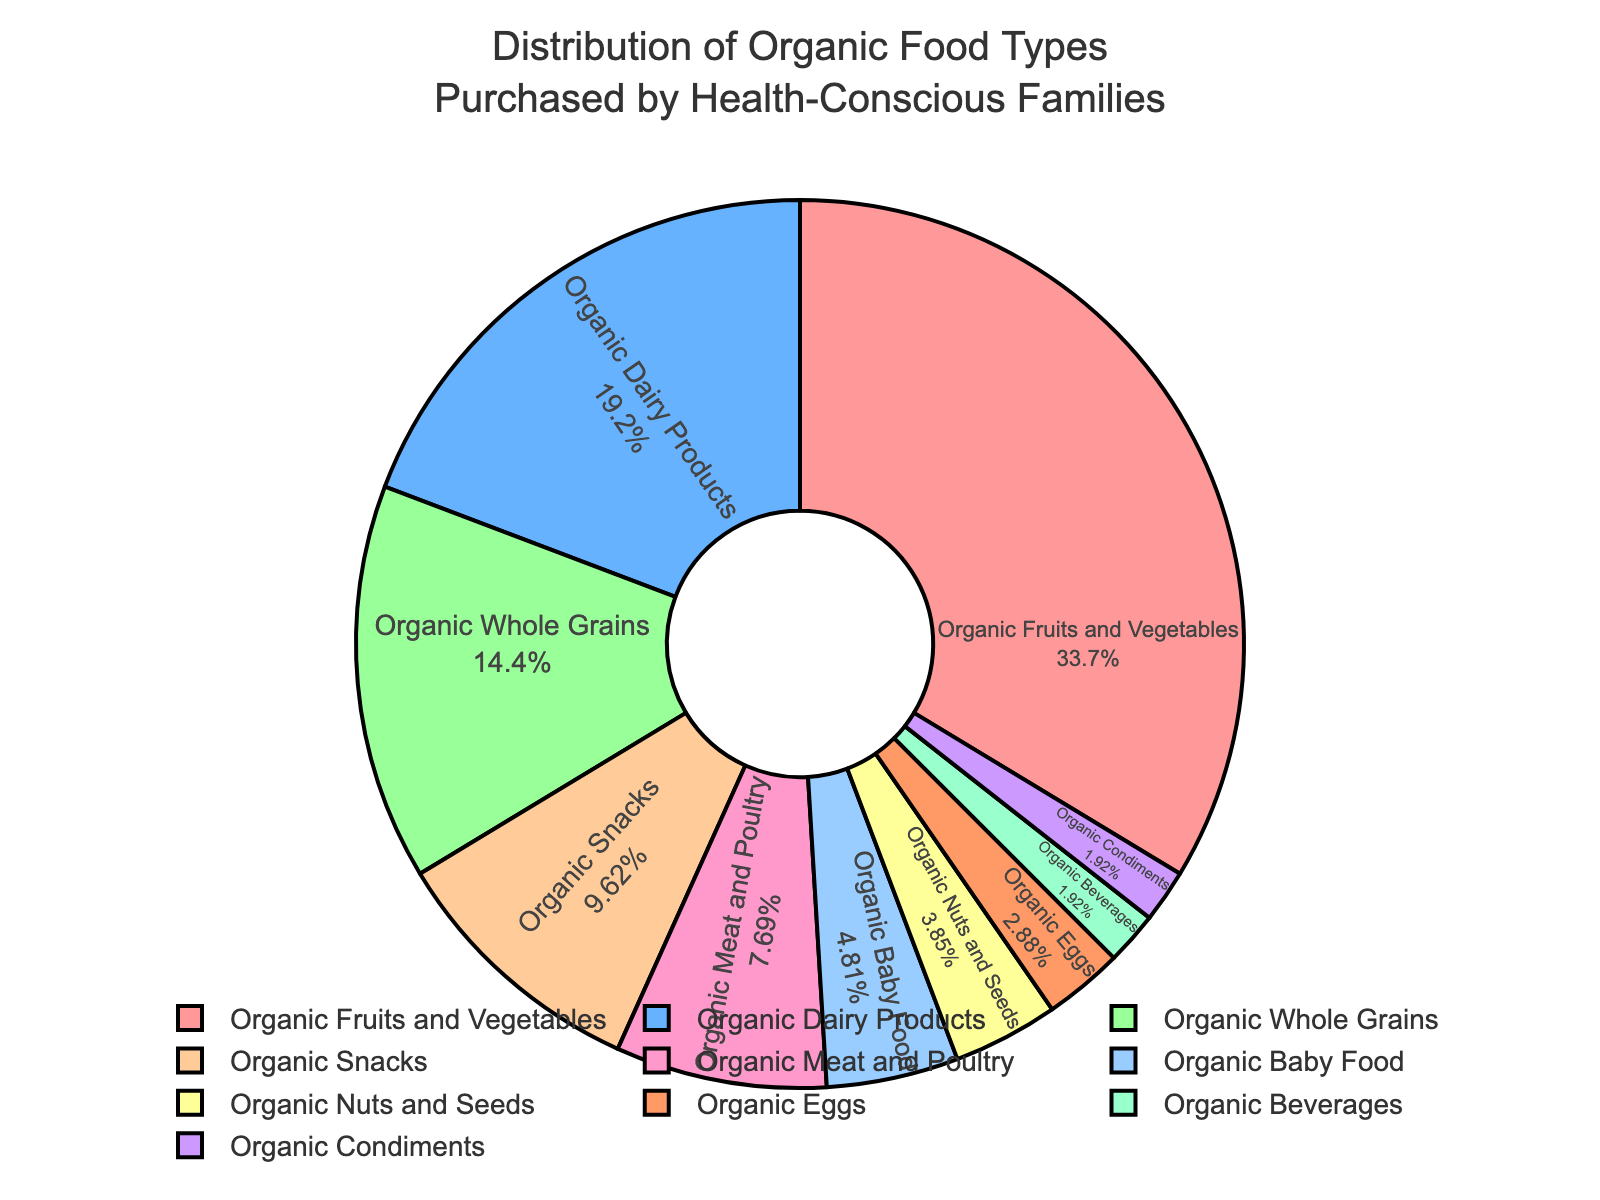What's the most purchased category of organic food by health-conscious families? The figure shows the distribution of organic food types, and we can see that the largest segment is labeled "Organic Fruits and Vegetables" with 35%.
Answer: Organic Fruits and Vegetables Which category has a higher percentage: Organic Dairy Products or Organic Whole Grains? By comparing the percentages of "Organic Dairy Products" (20%) and "Organic Whole Grains" (15%), it's clear that Organic Dairy Products have a higher percentage.
Answer: Organic Dairy Products What is the combined percentage of Organic Snacks, Organic Beverages, and Organic Condiments? Adding the percentages of Organic Snacks (10%), Organic Beverages (2%), and Organic Condiments (2%), we get 10% + 2% + 2% = 14%.
Answer: 14% Are Organic Meat and Poultry purchased more or less than Organic Baby Food? Comparing the percentages, Organic Meat and Poultry is 8%, and Organic Baby Food is 5%, indicating that Organic Meat and Poultry is purchased more.
Answer: More How much more percentage is spent on Organic Fruits and Vegetables compared to Organic Dairy Products? Subtract the percentage of Organic Dairy Products (20%) from the percentage of Organic Fruits and Vegetables (35%) to find the difference: 35% - 20% = 15%.
Answer: 15% What percentage of the purchases is made up by categories that have less than 10% each? Categories with less than 10% are Organic Meat and Poultry (8%), Organic Baby Food (5%), Organic Nuts and Seeds (4%), Organic Eggs (3%), Organic Beverages (2%), and Organic Condiments (2%). Adding these percentages: 8% + 5% + 4% + 3% + 2% + 2% = 24%.
Answer: 24% Which category has the smallest percentage of purchases, and what is that percentage? The smallest segment is labeled "Organic Condiments" with 2%.
Answer: Organic Condiments, 2% What is the total percentage of the top three categories combined? The top three categories are Organic Fruits and Vegetables (35%), Organic Dairy Products (20%), and Organic Whole Grains (15%). Adding these percentages gives: 35% + 20% + 15% = 70%.
Answer: 70% Is the percentage of Organic Nuts and Seeds more than twice the percentage of Organic Eggs? The percentage of Organic Nuts and Seeds is 4%, while Organic Eggs is 3%. Twice the percentage of Organic Eggs is 3% * 2 = 6%. Since 4% is less than 6%, Organic Nuts and Seeds are not more than twice the percentage of Organic Eggs.
Answer: No Among the categories with less than 5% purchases, which one has the highest percentage? Categories with less than 5% are Organic Baby Food (5%), Organic Nuts and Seeds (4%), Organic Eggs (3%), Organic Beverages (2%), and Organic Condiments (2%). The highest here is Organic Baby Food with 5%.
Answer: Organic Baby Food 